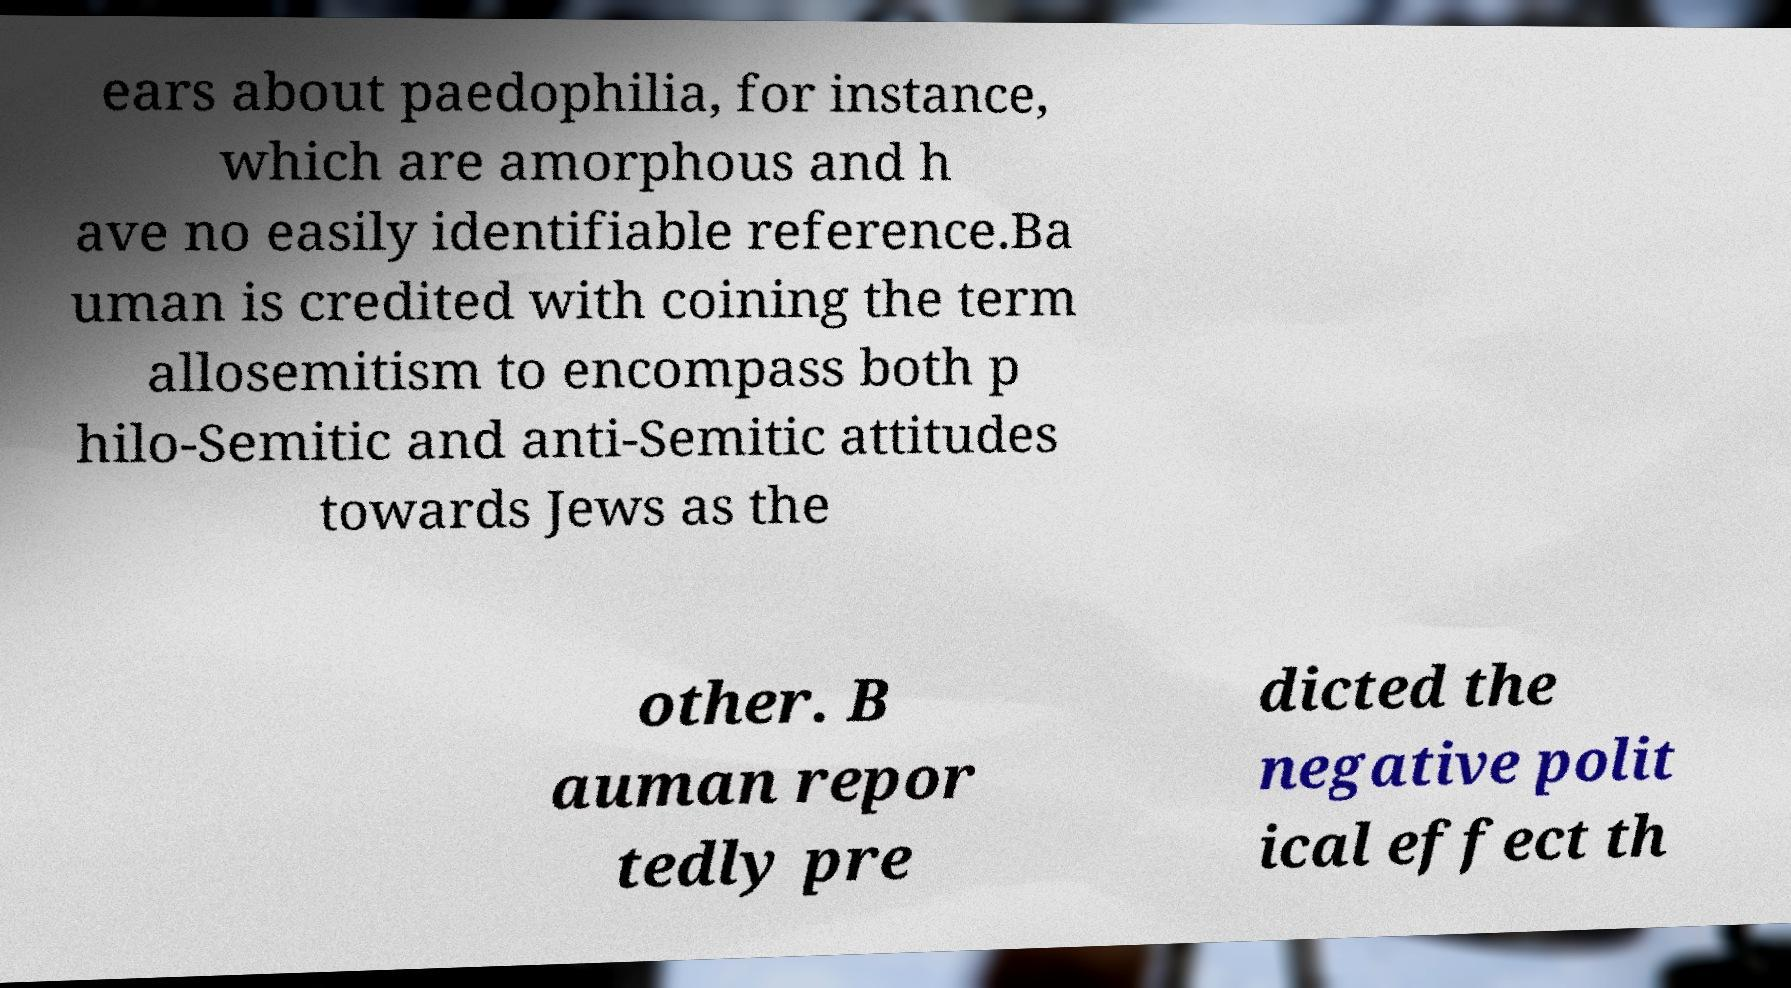Could you extract and type out the text from this image? ears about paedophilia, for instance, which are amorphous and h ave no easily identifiable reference.Ba uman is credited with coining the term allosemitism to encompass both p hilo-Semitic and anti-Semitic attitudes towards Jews as the other. B auman repor tedly pre dicted the negative polit ical effect th 